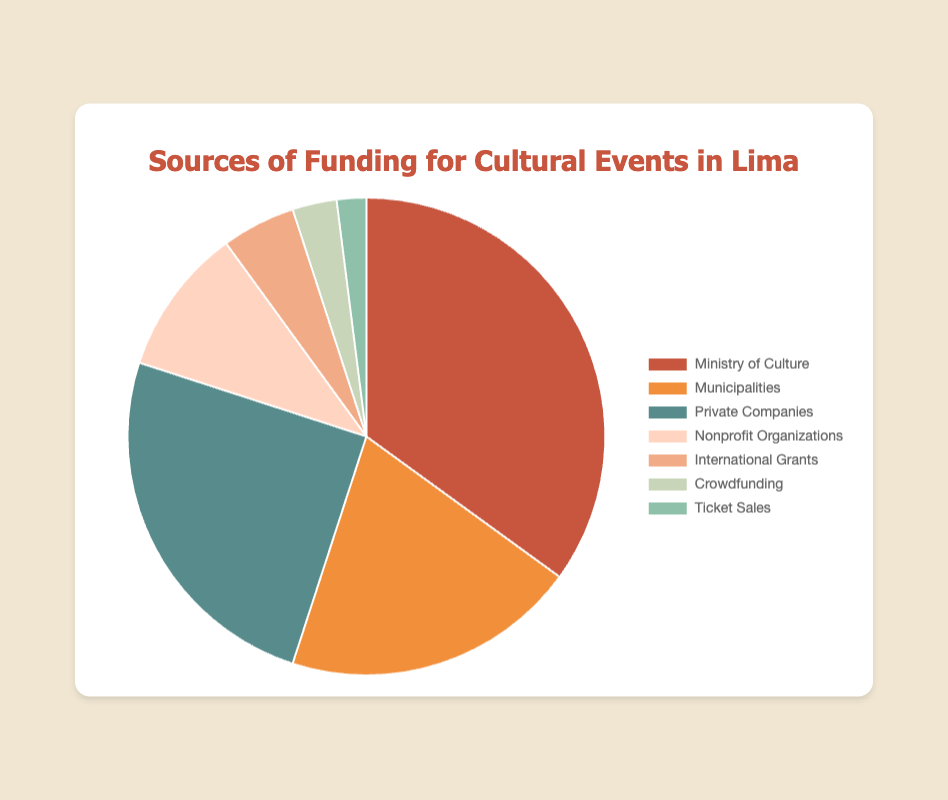What is the main source of funding for cultural events? The largest portion of the pie chart is represented by the Ministry of Culture, which contributes 35% of the funding.
Answer: Ministry of Culture How does the funding from private companies compare to that from municipalities? The pie chart shows that private companies contribute 25%, while municipalities provide 20%, meaning private companies offer 5% more funding.
Answer: Private companies provide 5% more Which funding sources contribute equally to the total funding? Looking at the pie chart, no two sources contribute exactly the same percentage.
Answer: None What is the combined percentage of funding from nonprofit organizations and international grants? Nonprofit organizations contribute 10% and international grants 5%, leading to a combined total of 15%.
Answer: 15% Which source contributes the least to the funding and what percentage does it represent? The smallest slice of the pie chart is for ticket sales, which contributes 2%.
Answer: Ticket sales, 2% How much more does the Ministry of Culture contribute compared to crowdfunding? The Ministry of Culture contributes 35%, while crowdfunding contributes 3%. The difference is 35% - 3% = 32%.
Answer: 32% What is the visual difference between the funding from municipalities and the Ministry of Culture? The Ministry of Culture is represented by a larger slice of the pie chart (35%) compared to municipalities (20%).
Answer: Larger slice for Ministry of Culture How does the funding from international grants compare to the combined funding from crowdfunding and ticket sales? International grants provide 5%, while crowdfunding and ticket sales together contribute 3% + 2% = 5%. They provide equal funding.
Answer: Equal 